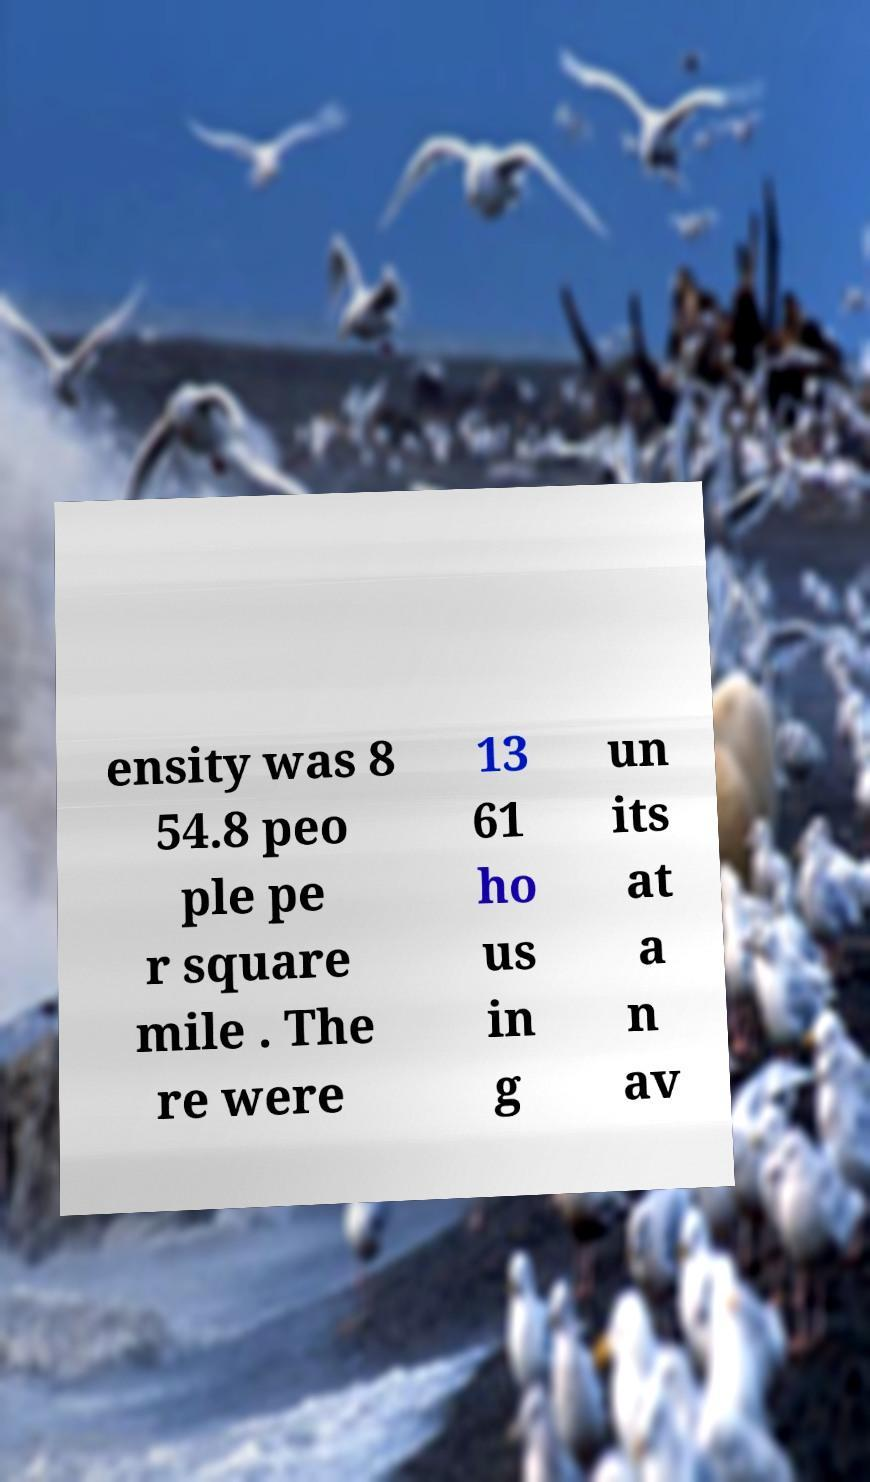Can you accurately transcribe the text from the provided image for me? ensity was 8 54.8 peo ple pe r square mile . The re were 13 61 ho us in g un its at a n av 